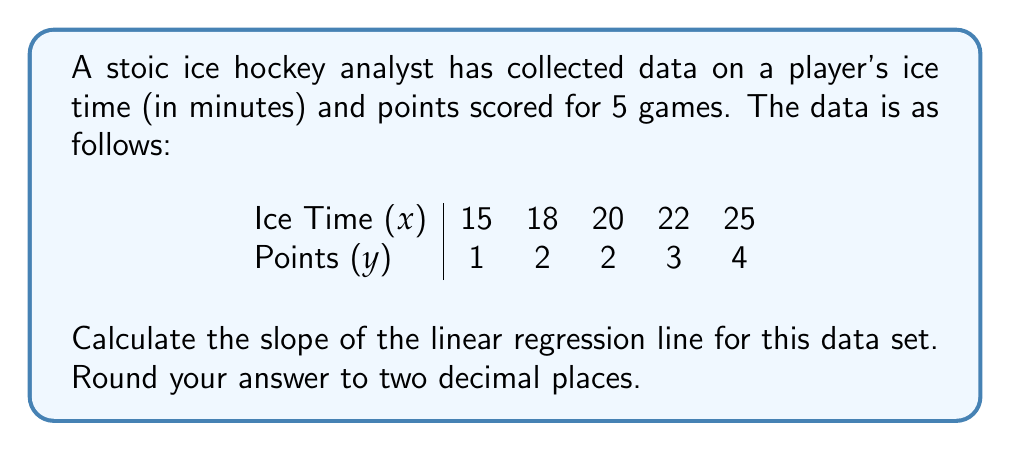Show me your answer to this math problem. To calculate the slope of the linear regression line, we'll use the formula:

$$ m = \frac{n\sum xy - \sum x \sum y}{n\sum x^2 - (\sum x)^2} $$

Where:
$n$ = number of data points
$x$ = ice time
$y$ = points scored

Step 1: Calculate the necessary sums:
$n = 5$
$\sum x = 15 + 18 + 20 + 22 + 25 = 100$
$\sum y = 1 + 2 + 2 + 3 + 4 = 12$
$\sum xy = (15)(1) + (18)(2) + (20)(2) + (22)(3) + (25)(4) = 256$
$\sum x^2 = 15^2 + 18^2 + 20^2 + 22^2 + 25^2 = 2098$

Step 2: Substitute these values into the slope formula:

$$ m = \frac{5(256) - (100)(12)}{5(2098) - (100)^2} $$

Step 3: Simplify:

$$ m = \frac{1280 - 1200}{10490 - 10000} = \frac{80}{490} $$

Step 4: Calculate and round to two decimal places:

$$ m \approx 0.16 $$
Answer: 0.16 